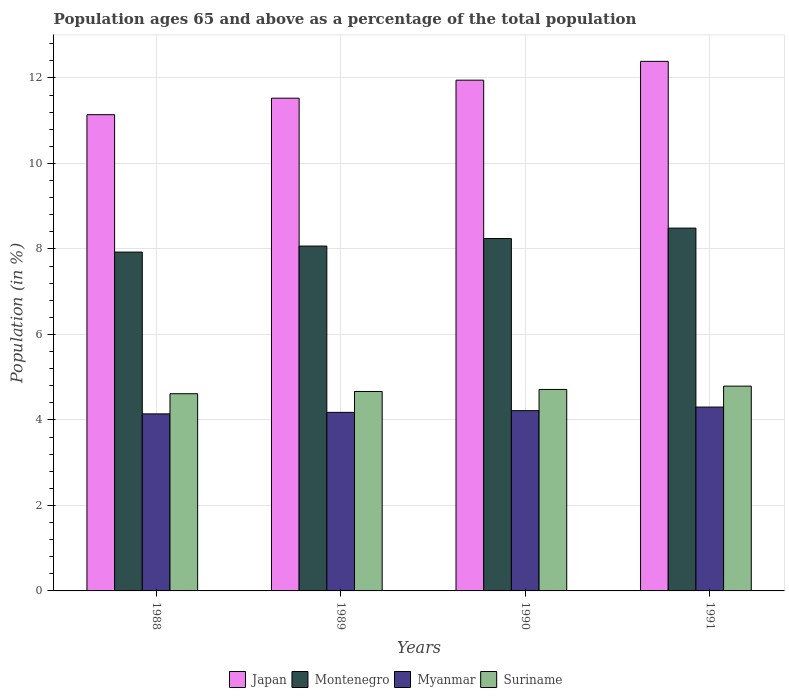How many different coloured bars are there?
Your answer should be compact. 4. Are the number of bars per tick equal to the number of legend labels?
Provide a succinct answer. Yes. How many bars are there on the 4th tick from the right?
Provide a succinct answer. 4. In how many cases, is the number of bars for a given year not equal to the number of legend labels?
Offer a very short reply. 0. What is the percentage of the population ages 65 and above in Suriname in 1988?
Offer a very short reply. 4.61. Across all years, what is the maximum percentage of the population ages 65 and above in Montenegro?
Keep it short and to the point. 8.49. Across all years, what is the minimum percentage of the population ages 65 and above in Japan?
Offer a very short reply. 11.14. In which year was the percentage of the population ages 65 and above in Myanmar minimum?
Your response must be concise. 1988. What is the total percentage of the population ages 65 and above in Montenegro in the graph?
Ensure brevity in your answer.  32.72. What is the difference between the percentage of the population ages 65 and above in Suriname in 1989 and that in 1990?
Give a very brief answer. -0.05. What is the difference between the percentage of the population ages 65 and above in Japan in 1988 and the percentage of the population ages 65 and above in Suriname in 1990?
Keep it short and to the point. 6.43. What is the average percentage of the population ages 65 and above in Montenegro per year?
Provide a short and direct response. 8.18. In the year 1991, what is the difference between the percentage of the population ages 65 and above in Japan and percentage of the population ages 65 and above in Suriname?
Make the answer very short. 7.6. In how many years, is the percentage of the population ages 65 and above in Myanmar greater than 12.4?
Your answer should be compact. 0. What is the ratio of the percentage of the population ages 65 and above in Suriname in 1989 to that in 1990?
Your answer should be compact. 0.99. Is the percentage of the population ages 65 and above in Montenegro in 1988 less than that in 1989?
Your response must be concise. Yes. What is the difference between the highest and the second highest percentage of the population ages 65 and above in Montenegro?
Provide a succinct answer. 0.24. What is the difference between the highest and the lowest percentage of the population ages 65 and above in Montenegro?
Provide a succinct answer. 0.56. Is the sum of the percentage of the population ages 65 and above in Montenegro in 1990 and 1991 greater than the maximum percentage of the population ages 65 and above in Suriname across all years?
Make the answer very short. Yes. What does the 2nd bar from the left in 1989 represents?
Provide a succinct answer. Montenegro. What does the 2nd bar from the right in 1991 represents?
Give a very brief answer. Myanmar. How many bars are there?
Offer a very short reply. 16. How many years are there in the graph?
Offer a very short reply. 4. What is the difference between two consecutive major ticks on the Y-axis?
Your answer should be very brief. 2. Are the values on the major ticks of Y-axis written in scientific E-notation?
Ensure brevity in your answer.  No. Does the graph contain grids?
Give a very brief answer. Yes. Where does the legend appear in the graph?
Keep it short and to the point. Bottom center. How many legend labels are there?
Keep it short and to the point. 4. What is the title of the graph?
Offer a very short reply. Population ages 65 and above as a percentage of the total population. What is the label or title of the X-axis?
Provide a short and direct response. Years. What is the Population (in %) of Japan in 1988?
Your response must be concise. 11.14. What is the Population (in %) in Montenegro in 1988?
Provide a short and direct response. 7.93. What is the Population (in %) of Myanmar in 1988?
Give a very brief answer. 4.14. What is the Population (in %) in Suriname in 1988?
Keep it short and to the point. 4.61. What is the Population (in %) in Japan in 1989?
Offer a very short reply. 11.53. What is the Population (in %) in Montenegro in 1989?
Give a very brief answer. 8.07. What is the Population (in %) in Myanmar in 1989?
Your answer should be very brief. 4.18. What is the Population (in %) in Suriname in 1989?
Offer a terse response. 4.67. What is the Population (in %) of Japan in 1990?
Your answer should be very brief. 11.95. What is the Population (in %) in Montenegro in 1990?
Offer a terse response. 8.24. What is the Population (in %) in Myanmar in 1990?
Ensure brevity in your answer.  4.22. What is the Population (in %) of Suriname in 1990?
Keep it short and to the point. 4.71. What is the Population (in %) in Japan in 1991?
Offer a very short reply. 12.39. What is the Population (in %) in Montenegro in 1991?
Keep it short and to the point. 8.49. What is the Population (in %) in Myanmar in 1991?
Offer a very short reply. 4.3. What is the Population (in %) of Suriname in 1991?
Make the answer very short. 4.79. Across all years, what is the maximum Population (in %) of Japan?
Give a very brief answer. 12.39. Across all years, what is the maximum Population (in %) of Montenegro?
Provide a succinct answer. 8.49. Across all years, what is the maximum Population (in %) of Myanmar?
Make the answer very short. 4.3. Across all years, what is the maximum Population (in %) of Suriname?
Your response must be concise. 4.79. Across all years, what is the minimum Population (in %) of Japan?
Give a very brief answer. 11.14. Across all years, what is the minimum Population (in %) of Montenegro?
Make the answer very short. 7.93. Across all years, what is the minimum Population (in %) in Myanmar?
Keep it short and to the point. 4.14. Across all years, what is the minimum Population (in %) in Suriname?
Your response must be concise. 4.61. What is the total Population (in %) in Japan in the graph?
Provide a succinct answer. 47. What is the total Population (in %) in Montenegro in the graph?
Keep it short and to the point. 32.72. What is the total Population (in %) in Myanmar in the graph?
Your answer should be very brief. 16.84. What is the total Population (in %) in Suriname in the graph?
Your answer should be compact. 18.78. What is the difference between the Population (in %) in Japan in 1988 and that in 1989?
Make the answer very short. -0.39. What is the difference between the Population (in %) of Montenegro in 1988 and that in 1989?
Ensure brevity in your answer.  -0.14. What is the difference between the Population (in %) of Myanmar in 1988 and that in 1989?
Offer a very short reply. -0.04. What is the difference between the Population (in %) of Suriname in 1988 and that in 1989?
Your answer should be very brief. -0.05. What is the difference between the Population (in %) of Japan in 1988 and that in 1990?
Provide a succinct answer. -0.81. What is the difference between the Population (in %) in Montenegro in 1988 and that in 1990?
Provide a short and direct response. -0.32. What is the difference between the Population (in %) of Myanmar in 1988 and that in 1990?
Your response must be concise. -0.08. What is the difference between the Population (in %) in Suriname in 1988 and that in 1990?
Offer a terse response. -0.1. What is the difference between the Population (in %) of Japan in 1988 and that in 1991?
Offer a terse response. -1.25. What is the difference between the Population (in %) of Montenegro in 1988 and that in 1991?
Your answer should be very brief. -0.56. What is the difference between the Population (in %) of Myanmar in 1988 and that in 1991?
Offer a terse response. -0.16. What is the difference between the Population (in %) of Suriname in 1988 and that in 1991?
Your answer should be very brief. -0.18. What is the difference between the Population (in %) of Japan in 1989 and that in 1990?
Keep it short and to the point. -0.42. What is the difference between the Population (in %) in Montenegro in 1989 and that in 1990?
Provide a short and direct response. -0.18. What is the difference between the Population (in %) in Myanmar in 1989 and that in 1990?
Offer a very short reply. -0.04. What is the difference between the Population (in %) of Suriname in 1989 and that in 1990?
Give a very brief answer. -0.05. What is the difference between the Population (in %) in Japan in 1989 and that in 1991?
Your answer should be compact. -0.86. What is the difference between the Population (in %) of Montenegro in 1989 and that in 1991?
Give a very brief answer. -0.42. What is the difference between the Population (in %) of Myanmar in 1989 and that in 1991?
Offer a terse response. -0.12. What is the difference between the Population (in %) of Suriname in 1989 and that in 1991?
Provide a succinct answer. -0.13. What is the difference between the Population (in %) of Japan in 1990 and that in 1991?
Make the answer very short. -0.44. What is the difference between the Population (in %) of Montenegro in 1990 and that in 1991?
Make the answer very short. -0.24. What is the difference between the Population (in %) of Myanmar in 1990 and that in 1991?
Ensure brevity in your answer.  -0.08. What is the difference between the Population (in %) of Suriname in 1990 and that in 1991?
Ensure brevity in your answer.  -0.08. What is the difference between the Population (in %) in Japan in 1988 and the Population (in %) in Montenegro in 1989?
Make the answer very short. 3.07. What is the difference between the Population (in %) of Japan in 1988 and the Population (in %) of Myanmar in 1989?
Offer a very short reply. 6.96. What is the difference between the Population (in %) in Japan in 1988 and the Population (in %) in Suriname in 1989?
Keep it short and to the point. 6.48. What is the difference between the Population (in %) in Montenegro in 1988 and the Population (in %) in Myanmar in 1989?
Your response must be concise. 3.75. What is the difference between the Population (in %) of Montenegro in 1988 and the Population (in %) of Suriname in 1989?
Offer a very short reply. 3.26. What is the difference between the Population (in %) of Myanmar in 1988 and the Population (in %) of Suriname in 1989?
Provide a succinct answer. -0.52. What is the difference between the Population (in %) of Japan in 1988 and the Population (in %) of Montenegro in 1990?
Your response must be concise. 2.9. What is the difference between the Population (in %) in Japan in 1988 and the Population (in %) in Myanmar in 1990?
Provide a succinct answer. 6.92. What is the difference between the Population (in %) of Japan in 1988 and the Population (in %) of Suriname in 1990?
Ensure brevity in your answer.  6.43. What is the difference between the Population (in %) in Montenegro in 1988 and the Population (in %) in Myanmar in 1990?
Give a very brief answer. 3.71. What is the difference between the Population (in %) of Montenegro in 1988 and the Population (in %) of Suriname in 1990?
Your response must be concise. 3.21. What is the difference between the Population (in %) of Myanmar in 1988 and the Population (in %) of Suriname in 1990?
Provide a succinct answer. -0.57. What is the difference between the Population (in %) of Japan in 1988 and the Population (in %) of Montenegro in 1991?
Keep it short and to the point. 2.65. What is the difference between the Population (in %) of Japan in 1988 and the Population (in %) of Myanmar in 1991?
Provide a succinct answer. 6.84. What is the difference between the Population (in %) in Japan in 1988 and the Population (in %) in Suriname in 1991?
Give a very brief answer. 6.35. What is the difference between the Population (in %) of Montenegro in 1988 and the Population (in %) of Myanmar in 1991?
Your answer should be compact. 3.63. What is the difference between the Population (in %) of Montenegro in 1988 and the Population (in %) of Suriname in 1991?
Ensure brevity in your answer.  3.14. What is the difference between the Population (in %) in Myanmar in 1988 and the Population (in %) in Suriname in 1991?
Offer a terse response. -0.65. What is the difference between the Population (in %) of Japan in 1989 and the Population (in %) of Montenegro in 1990?
Give a very brief answer. 3.28. What is the difference between the Population (in %) of Japan in 1989 and the Population (in %) of Myanmar in 1990?
Your response must be concise. 7.31. What is the difference between the Population (in %) in Japan in 1989 and the Population (in %) in Suriname in 1990?
Keep it short and to the point. 6.81. What is the difference between the Population (in %) in Montenegro in 1989 and the Population (in %) in Myanmar in 1990?
Provide a succinct answer. 3.85. What is the difference between the Population (in %) in Montenegro in 1989 and the Population (in %) in Suriname in 1990?
Provide a succinct answer. 3.35. What is the difference between the Population (in %) in Myanmar in 1989 and the Population (in %) in Suriname in 1990?
Offer a terse response. -0.54. What is the difference between the Population (in %) of Japan in 1989 and the Population (in %) of Montenegro in 1991?
Provide a succinct answer. 3.04. What is the difference between the Population (in %) in Japan in 1989 and the Population (in %) in Myanmar in 1991?
Offer a very short reply. 7.23. What is the difference between the Population (in %) of Japan in 1989 and the Population (in %) of Suriname in 1991?
Your answer should be compact. 6.74. What is the difference between the Population (in %) of Montenegro in 1989 and the Population (in %) of Myanmar in 1991?
Your answer should be very brief. 3.77. What is the difference between the Population (in %) of Montenegro in 1989 and the Population (in %) of Suriname in 1991?
Your answer should be very brief. 3.28. What is the difference between the Population (in %) of Myanmar in 1989 and the Population (in %) of Suriname in 1991?
Offer a very short reply. -0.61. What is the difference between the Population (in %) in Japan in 1990 and the Population (in %) in Montenegro in 1991?
Your answer should be very brief. 3.46. What is the difference between the Population (in %) of Japan in 1990 and the Population (in %) of Myanmar in 1991?
Your answer should be very brief. 7.65. What is the difference between the Population (in %) in Japan in 1990 and the Population (in %) in Suriname in 1991?
Keep it short and to the point. 7.16. What is the difference between the Population (in %) of Montenegro in 1990 and the Population (in %) of Myanmar in 1991?
Your response must be concise. 3.94. What is the difference between the Population (in %) in Montenegro in 1990 and the Population (in %) in Suriname in 1991?
Ensure brevity in your answer.  3.45. What is the difference between the Population (in %) in Myanmar in 1990 and the Population (in %) in Suriname in 1991?
Offer a terse response. -0.57. What is the average Population (in %) in Japan per year?
Keep it short and to the point. 11.75. What is the average Population (in %) of Montenegro per year?
Make the answer very short. 8.18. What is the average Population (in %) in Myanmar per year?
Make the answer very short. 4.21. What is the average Population (in %) in Suriname per year?
Provide a succinct answer. 4.7. In the year 1988, what is the difference between the Population (in %) in Japan and Population (in %) in Montenegro?
Provide a succinct answer. 3.21. In the year 1988, what is the difference between the Population (in %) in Japan and Population (in %) in Myanmar?
Ensure brevity in your answer.  7. In the year 1988, what is the difference between the Population (in %) in Japan and Population (in %) in Suriname?
Offer a very short reply. 6.53. In the year 1988, what is the difference between the Population (in %) in Montenegro and Population (in %) in Myanmar?
Provide a short and direct response. 3.78. In the year 1988, what is the difference between the Population (in %) of Montenegro and Population (in %) of Suriname?
Keep it short and to the point. 3.31. In the year 1988, what is the difference between the Population (in %) in Myanmar and Population (in %) in Suriname?
Make the answer very short. -0.47. In the year 1989, what is the difference between the Population (in %) of Japan and Population (in %) of Montenegro?
Offer a very short reply. 3.46. In the year 1989, what is the difference between the Population (in %) in Japan and Population (in %) in Myanmar?
Your answer should be very brief. 7.35. In the year 1989, what is the difference between the Population (in %) of Japan and Population (in %) of Suriname?
Your answer should be very brief. 6.86. In the year 1989, what is the difference between the Population (in %) in Montenegro and Population (in %) in Myanmar?
Your answer should be very brief. 3.89. In the year 1989, what is the difference between the Population (in %) in Montenegro and Population (in %) in Suriname?
Provide a short and direct response. 3.4. In the year 1989, what is the difference between the Population (in %) in Myanmar and Population (in %) in Suriname?
Ensure brevity in your answer.  -0.49. In the year 1990, what is the difference between the Population (in %) of Japan and Population (in %) of Montenegro?
Ensure brevity in your answer.  3.7. In the year 1990, what is the difference between the Population (in %) in Japan and Population (in %) in Myanmar?
Your response must be concise. 7.73. In the year 1990, what is the difference between the Population (in %) of Japan and Population (in %) of Suriname?
Offer a very short reply. 7.23. In the year 1990, what is the difference between the Population (in %) in Montenegro and Population (in %) in Myanmar?
Your answer should be very brief. 4.03. In the year 1990, what is the difference between the Population (in %) of Montenegro and Population (in %) of Suriname?
Provide a short and direct response. 3.53. In the year 1990, what is the difference between the Population (in %) of Myanmar and Population (in %) of Suriname?
Offer a terse response. -0.5. In the year 1991, what is the difference between the Population (in %) of Japan and Population (in %) of Montenegro?
Your answer should be compact. 3.9. In the year 1991, what is the difference between the Population (in %) in Japan and Population (in %) in Myanmar?
Your answer should be compact. 8.09. In the year 1991, what is the difference between the Population (in %) of Japan and Population (in %) of Suriname?
Keep it short and to the point. 7.6. In the year 1991, what is the difference between the Population (in %) of Montenegro and Population (in %) of Myanmar?
Ensure brevity in your answer.  4.19. In the year 1991, what is the difference between the Population (in %) of Montenegro and Population (in %) of Suriname?
Offer a terse response. 3.7. In the year 1991, what is the difference between the Population (in %) of Myanmar and Population (in %) of Suriname?
Offer a terse response. -0.49. What is the ratio of the Population (in %) of Japan in 1988 to that in 1989?
Make the answer very short. 0.97. What is the ratio of the Population (in %) of Montenegro in 1988 to that in 1989?
Make the answer very short. 0.98. What is the ratio of the Population (in %) in Myanmar in 1988 to that in 1989?
Ensure brevity in your answer.  0.99. What is the ratio of the Population (in %) in Suriname in 1988 to that in 1989?
Ensure brevity in your answer.  0.99. What is the ratio of the Population (in %) of Japan in 1988 to that in 1990?
Ensure brevity in your answer.  0.93. What is the ratio of the Population (in %) in Montenegro in 1988 to that in 1990?
Your response must be concise. 0.96. What is the ratio of the Population (in %) of Myanmar in 1988 to that in 1990?
Your response must be concise. 0.98. What is the ratio of the Population (in %) of Suriname in 1988 to that in 1990?
Provide a short and direct response. 0.98. What is the ratio of the Population (in %) of Japan in 1988 to that in 1991?
Make the answer very short. 0.9. What is the ratio of the Population (in %) in Montenegro in 1988 to that in 1991?
Make the answer very short. 0.93. What is the ratio of the Population (in %) in Myanmar in 1988 to that in 1991?
Make the answer very short. 0.96. What is the ratio of the Population (in %) of Suriname in 1988 to that in 1991?
Give a very brief answer. 0.96. What is the ratio of the Population (in %) of Japan in 1989 to that in 1990?
Your response must be concise. 0.96. What is the ratio of the Population (in %) of Montenegro in 1989 to that in 1990?
Offer a very short reply. 0.98. What is the ratio of the Population (in %) in Myanmar in 1989 to that in 1990?
Ensure brevity in your answer.  0.99. What is the ratio of the Population (in %) in Suriname in 1989 to that in 1990?
Your response must be concise. 0.99. What is the ratio of the Population (in %) in Japan in 1989 to that in 1991?
Provide a succinct answer. 0.93. What is the ratio of the Population (in %) in Montenegro in 1989 to that in 1991?
Your answer should be compact. 0.95. What is the ratio of the Population (in %) of Myanmar in 1989 to that in 1991?
Your response must be concise. 0.97. What is the ratio of the Population (in %) of Suriname in 1989 to that in 1991?
Your answer should be very brief. 0.97. What is the ratio of the Population (in %) of Japan in 1990 to that in 1991?
Keep it short and to the point. 0.96. What is the ratio of the Population (in %) in Montenegro in 1990 to that in 1991?
Make the answer very short. 0.97. What is the ratio of the Population (in %) in Myanmar in 1990 to that in 1991?
Your response must be concise. 0.98. What is the ratio of the Population (in %) in Suriname in 1990 to that in 1991?
Offer a terse response. 0.98. What is the difference between the highest and the second highest Population (in %) in Japan?
Provide a short and direct response. 0.44. What is the difference between the highest and the second highest Population (in %) in Montenegro?
Offer a very short reply. 0.24. What is the difference between the highest and the second highest Population (in %) in Myanmar?
Keep it short and to the point. 0.08. What is the difference between the highest and the second highest Population (in %) of Suriname?
Provide a succinct answer. 0.08. What is the difference between the highest and the lowest Population (in %) in Japan?
Your answer should be compact. 1.25. What is the difference between the highest and the lowest Population (in %) of Montenegro?
Offer a very short reply. 0.56. What is the difference between the highest and the lowest Population (in %) in Myanmar?
Give a very brief answer. 0.16. What is the difference between the highest and the lowest Population (in %) in Suriname?
Keep it short and to the point. 0.18. 